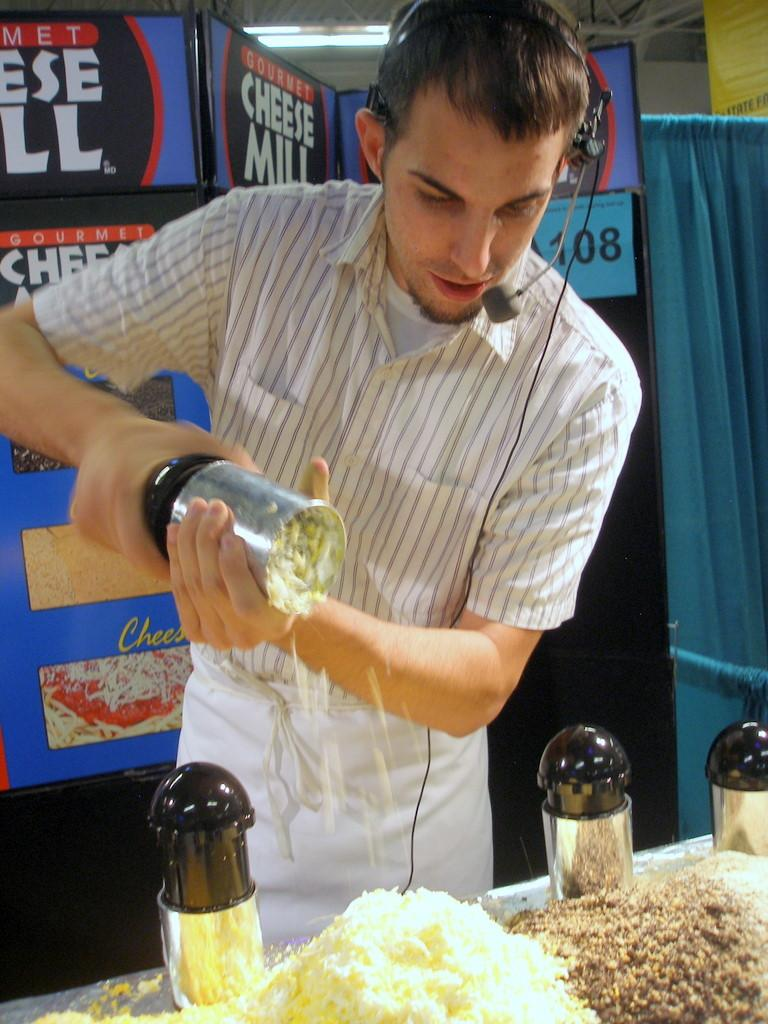Provide a one-sentence caption for the provided image. Chef shredding the Cheese of the  Cheese Mill Restaurant. 